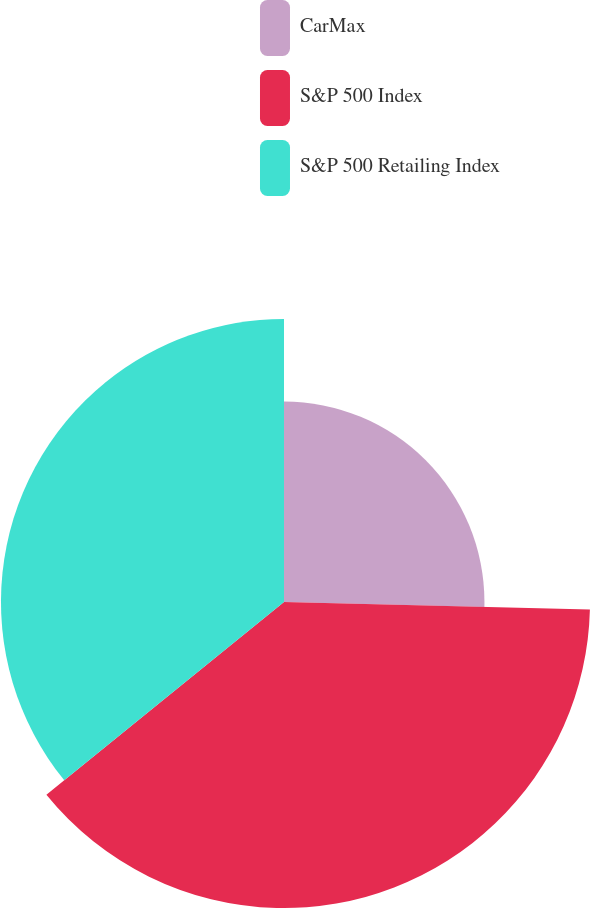Convert chart. <chart><loc_0><loc_0><loc_500><loc_500><pie_chart><fcel>CarMax<fcel>S&P 500 Index<fcel>S&P 500 Retailing Index<nl><fcel>25.39%<fcel>38.76%<fcel>35.85%<nl></chart> 